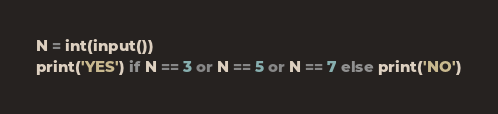Convert code to text. <code><loc_0><loc_0><loc_500><loc_500><_Python_>N = int(input())
print('YES') if N == 3 or N == 5 or N == 7 else print('NO')</code> 